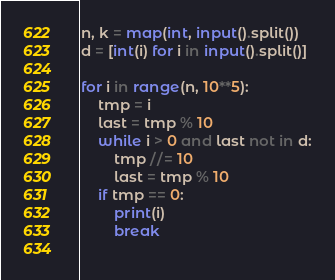Convert code to text. <code><loc_0><loc_0><loc_500><loc_500><_Python_>n, k = map(int, input().split())
d = [int(i) for i in input().split()]

for i in range(n, 10**5):
    tmp = i
    last = tmp % 10
    while i > 0 and last not in d:
        tmp //= 10
        last = tmp % 10
    if tmp == 0:
        print(i)
        break
    
</code> 